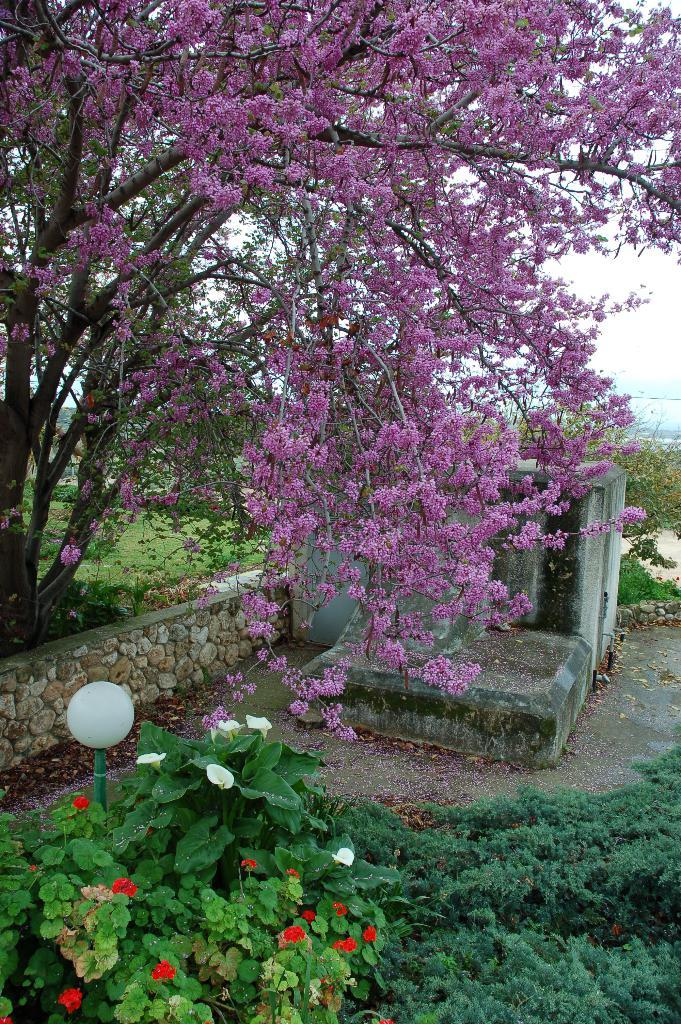What type of vegetation can be seen in the image? There are flowers, trees, and plants in the image. What type of artificial light source is present in the image? There is a lamp in the image. What type of structure is visible in the image? There is a building in the image. What is visible in the background of the image? The sky is visible in the background of the image. How many clocks are present in the image? There are no clocks visible in the image. What type of ball is being used in the competition depicted in the image? There is no competition or ball present in the image. 